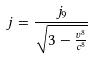<formula> <loc_0><loc_0><loc_500><loc_500>j = \frac { j _ { 9 } } { \sqrt { 3 - \frac { v ^ { 8 } } { c ^ { 8 } } } }</formula> 